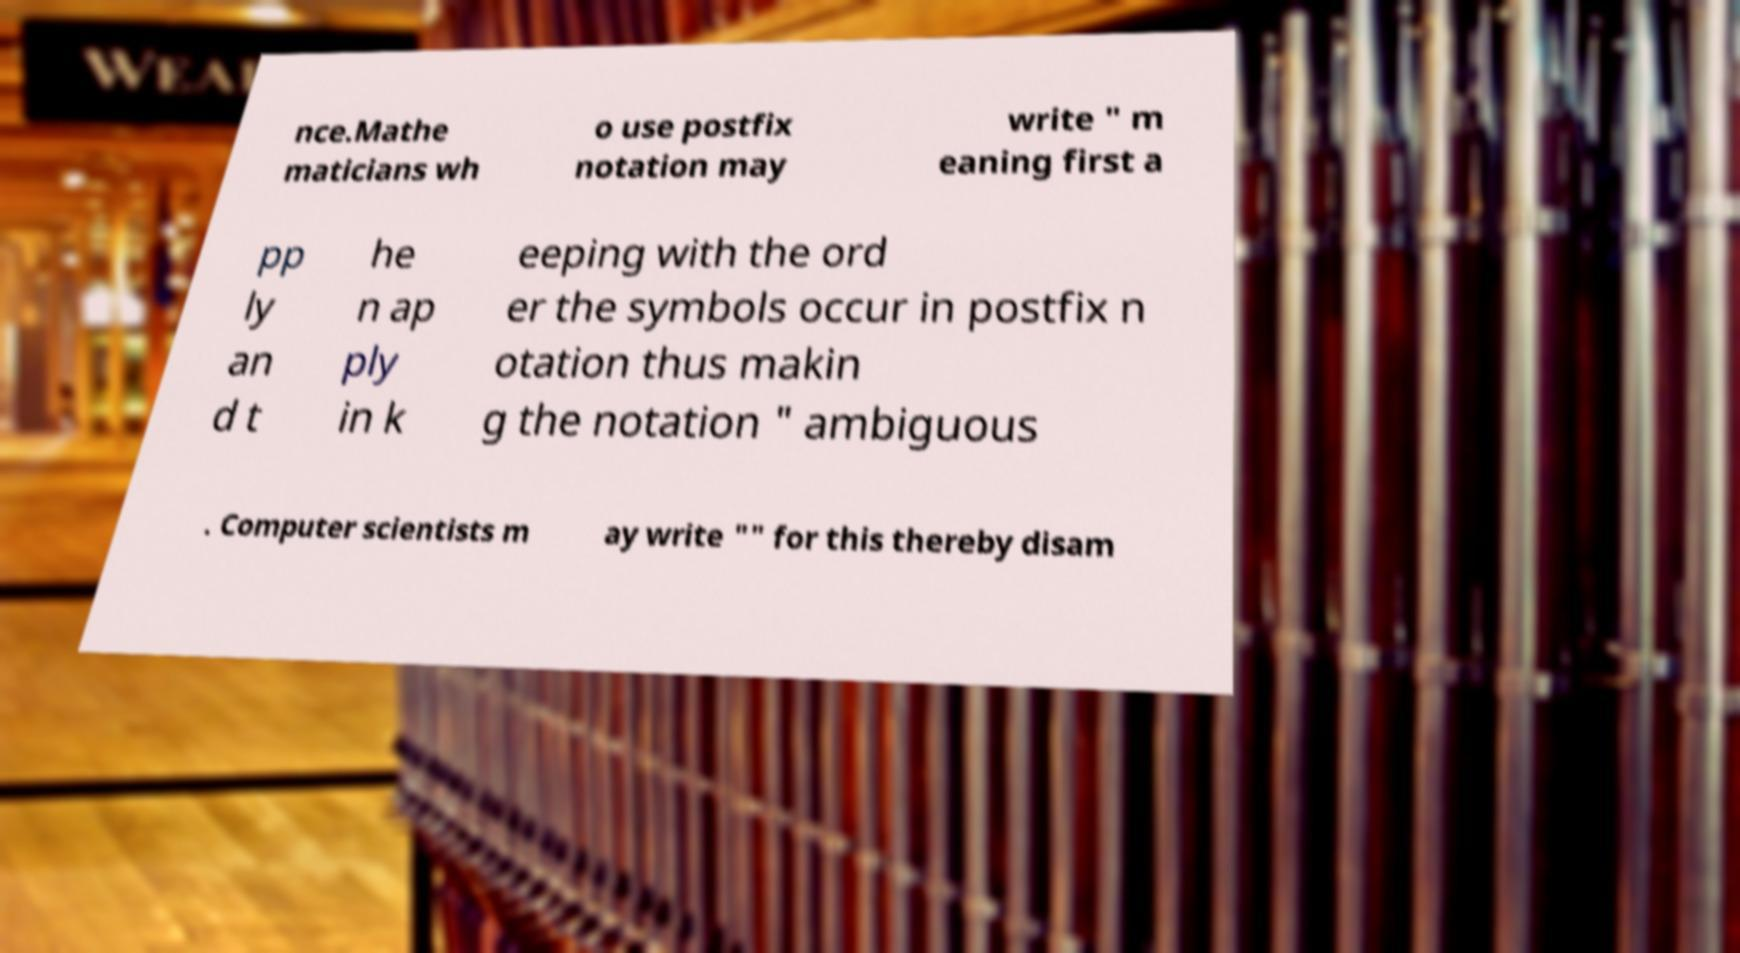Please identify and transcribe the text found in this image. nce.Mathe maticians wh o use postfix notation may write " m eaning first a pp ly an d t he n ap ply in k eeping with the ord er the symbols occur in postfix n otation thus makin g the notation " ambiguous . Computer scientists m ay write "" for this thereby disam 